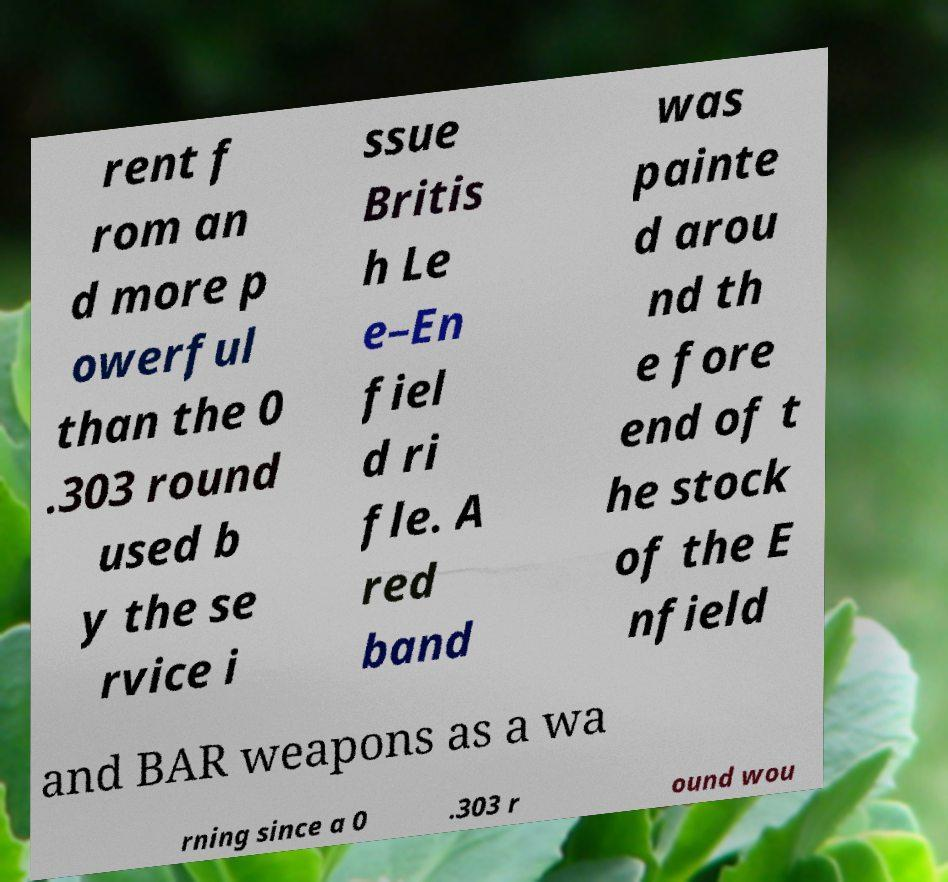Please read and relay the text visible in this image. What does it say? rent f rom an d more p owerful than the 0 .303 round used b y the se rvice i ssue Britis h Le e–En fiel d ri fle. A red band was painte d arou nd th e fore end of t he stock of the E nfield and BAR weapons as a wa rning since a 0 .303 r ound wou 